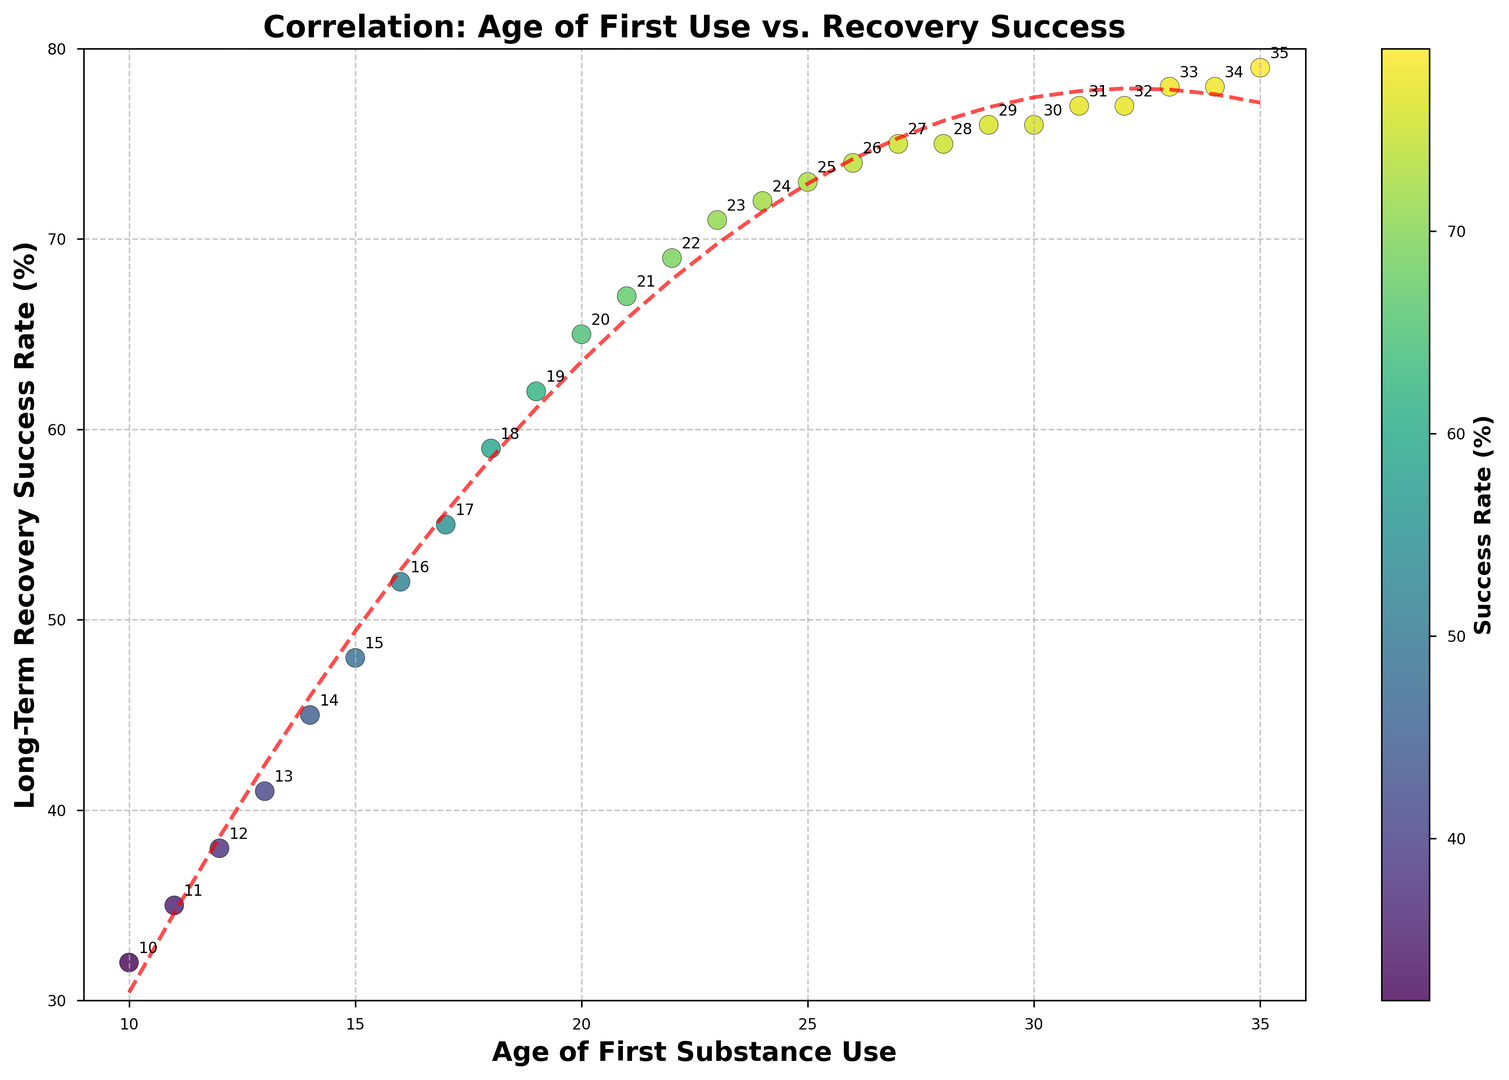What's the median age of first substance use in the data? To find the median, first list the ages in numerical order: 10, 11, 12, 13, 14, 15, 16, 17, 18, 19, 20, 21, 22, 23, 24, 25, 26, 27, 28, 29, 30, 31, 32, 33, 34, 35. The median is the middle value. For a dataset with 26 values, the median is the average of the 13th and 14th values. Here, 13th is 22, and 14th is 23, thus the median is (22 + 23) / 2 = 22.5
Answer: 22.5 At what age of first use is the long-term recovery success rate highest? By visually examining the peak of the scatter plot and referring to the annotations, the highest long-term recovery success rate of 79% occurs at the age of first use of 35.
Answer: 35 Which age group has a steep increase in recovery success rate compared to their adjacent groups? Looking at the trend line and scatter points, the steepest increase in recovery success rate occurs between the ages of 14 and 18. For example, from 14 (45%) to 18 (59%) the rise is 14%.
Answer: 14-18 How does the color change as the long-term recovery success rate increases? Observing the scatter plot, the color shifts from dark (lower success rates) to lighter shades of yellow-green (higher success rates) as the recovery success rate increases.
Answer: From dark to light What is the approximate success rate when the age of first use is 20? By locating the scatter point corresponding to age 20 and checking its position on the y-axis, the success rate is approximately 65%.
Answer: 65% Does the trend line indicate a linear or a non-linear relationship between age of first use and recovery success rate? From the scatter plot, the trend line is a red dashed curve which visually suggests a non-linear (specifically a quadratic) relationship rather than a straight line.
Answer: Non-linear Between the ages of 12 and 25, how much did the long-term recovery success rate increase? Finding the recovery success rate at age 12 (38%) and at age 25 (73%), the increase is calculated as 73% - 38% = 35%.
Answer: 35% What is the range of long-term recovery success rates present in the scatter plot? The lowest and highest long-term recovery success rates are 32% at age 10 and 79% at ages 34 and 35, respectively. Therefore, the range is 79% - 32% = 47%.
Answer: 47% Is there any age at which the success rate stops increasing and levels out? By examining the scatter plot, after age 27 the success rate levels out around 75-79% and no significant increase is observed.
Answer: Yes (around age 27) 